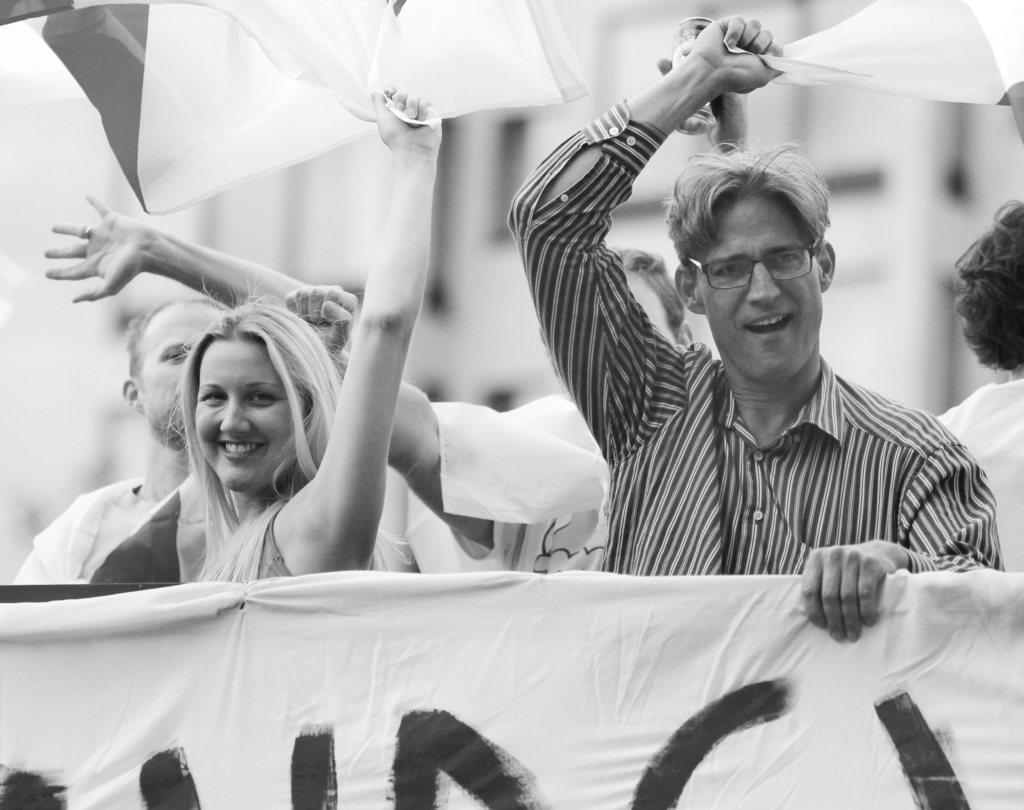Can you describe this image briefly? In this black and white image, we can see persons wearing clothes. There are two persons in the middle of the image holding clothes with their hands. There is a banner at the bottom of the image. In the background, image is blurred. 